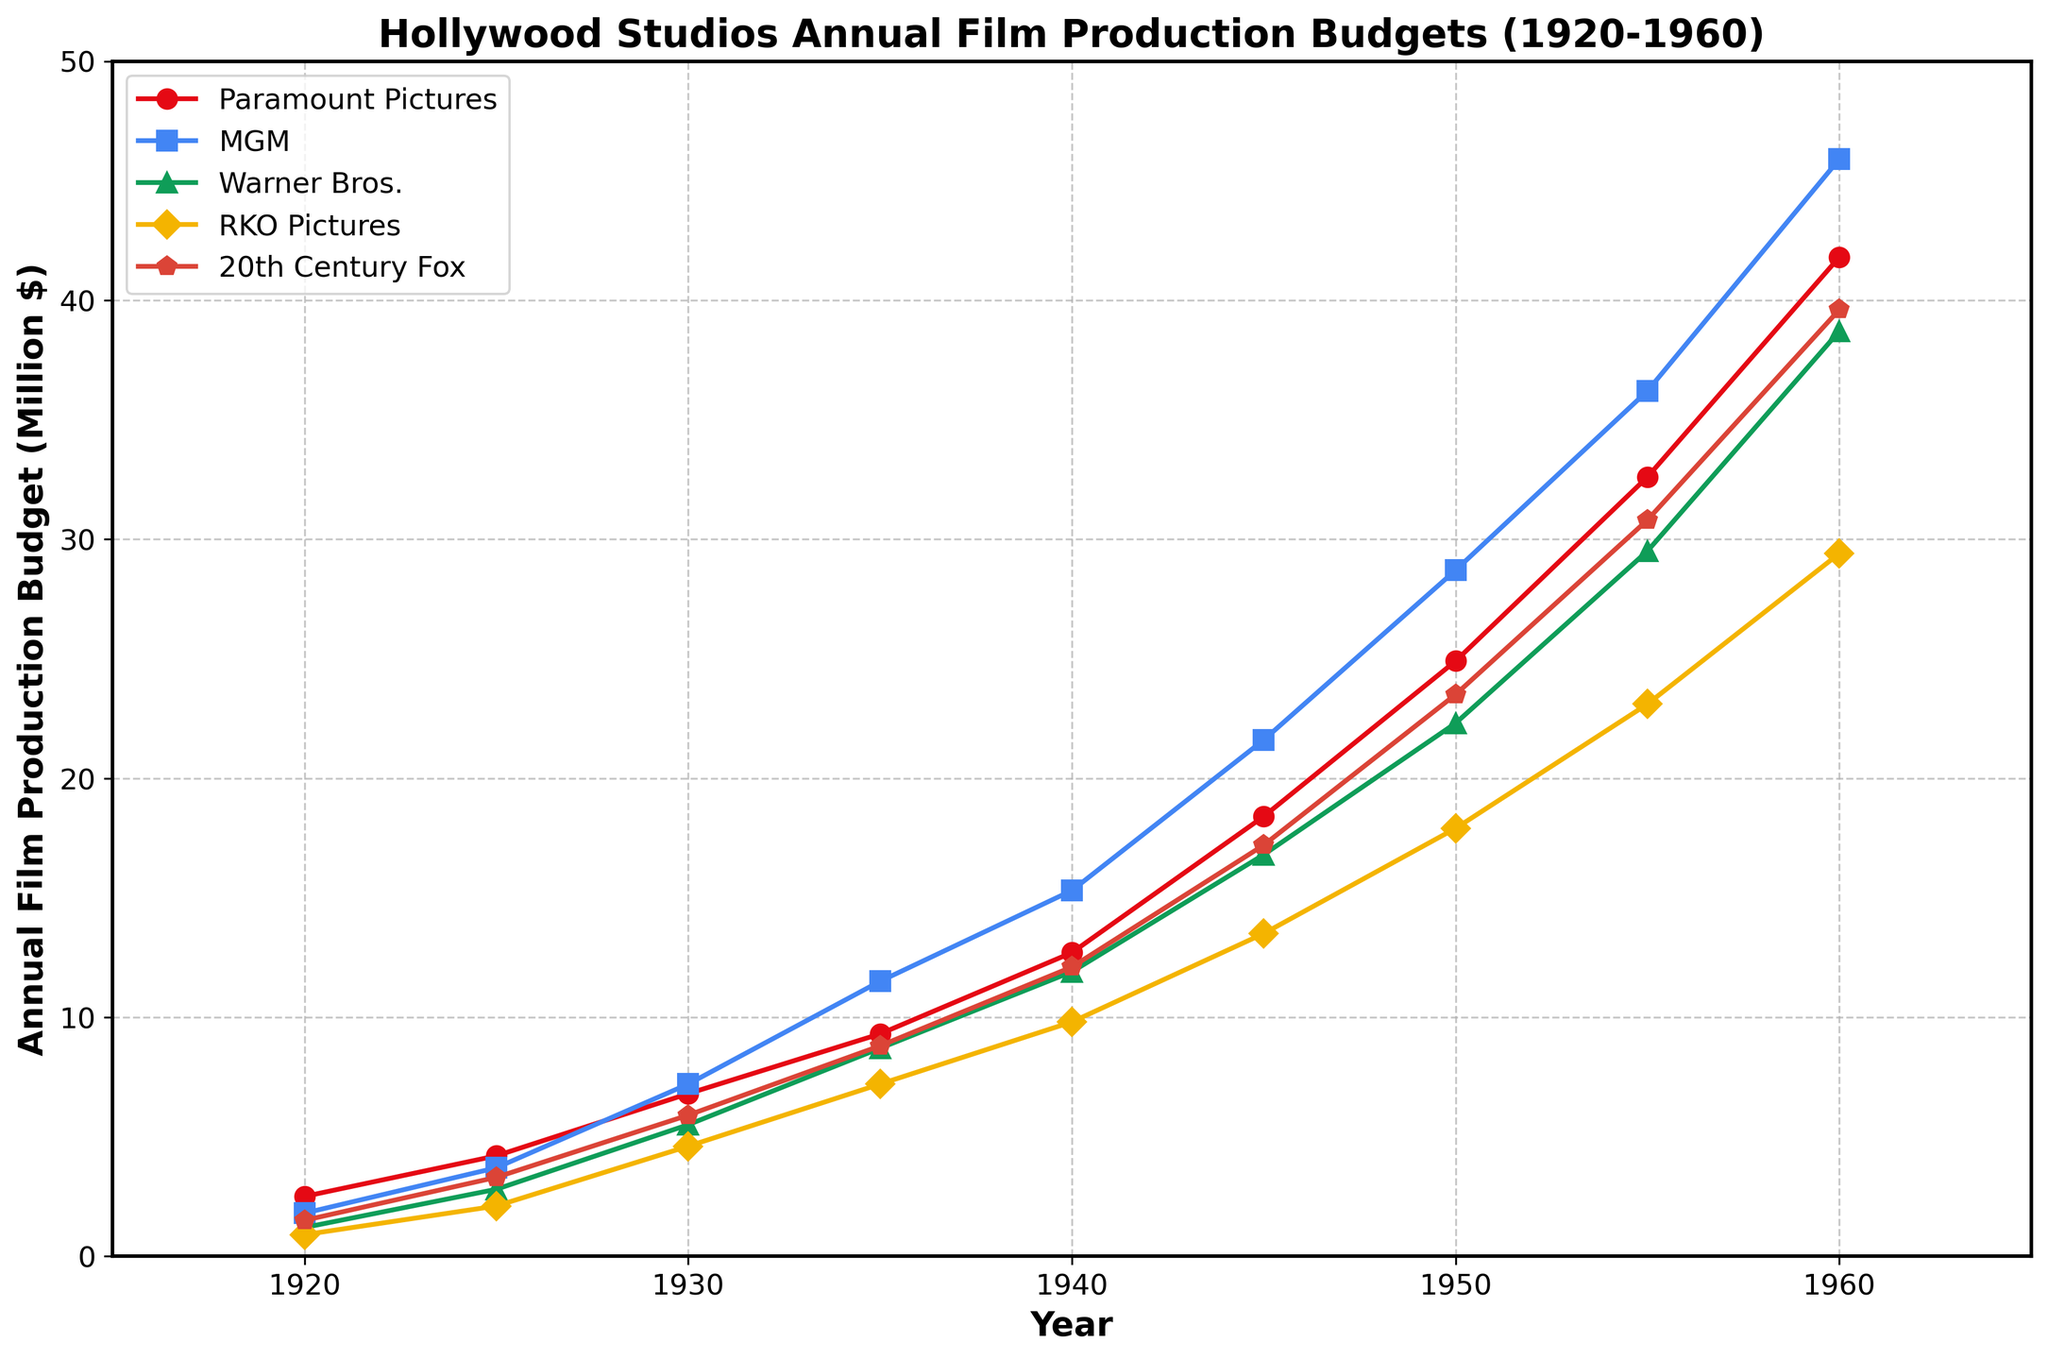What is the trend of annual film production budgets for MGM from 1920 to 1960? MGM's budget consistently increased from 1.8 million in 1920 to 45.9 million in 1960. I can see that the graph shows a steady upward trend for MGM through all the years displayed.
Answer: Upward trend Which studio had the highest annual film production budget in 1940? In 1940, the plot shows that MGM's budget was the highest at 15.3 million, compared to other studios' budgets for that year.
Answer: MGM Between Warner Bros. and RKO Pictures, which studio saw a larger absolute increase in their annual film production budget from 1925 to 1960? Warner Bros. increased from 2.8 million in 1925 to 38.7 million in 1960, an increase of 35.9 million. RKO Pictures increased from 2.1 million to 29.4 million, an increase of 27.3 million. So, Warner Bros. had a larger absolute increase.
Answer: Warner Bros What was the average annual film production budget for Paramount Pictures over the entire period (1920-1960)? Adding the budgets for Paramount Pictures (2.5, 4.2, 6.8, 9.3, 12.7, 18.4, 24.9, 32.6, 41.8) gives 153.2. Dividing by the number of years (9) gives an average of 153.2/9 = 17.02.
Answer: 17.02 million How much more did 20th Century Fox spend on annual film production in 1955 compared to their budget in 1935? 20th Century Fox's budget in 1955 was 30.8 million and in 1935 it was 8.8 million. The difference is 30.8 - 8.8 = 22 million.
Answer: 22 million Which studio had the smallest increase in annual film production budget from 1920 to 1930? From 1920 to 1930, Paramount Pictures increased from 2.5 to 6.8, MGM from 1.8 to 7.2, Warner Bros. from 1.2 to 5.5, RKO Pictures from 0.9 to 4.6, and 20th Century Fox from 1.5 to 5.9. The smallest increase is for RKO Pictures, which increased by 3.7 million.
Answer: RKO Pictures By how much did Warner Bros. exceed RKO Pictures in annual film production budget in 1960? In 1960, Warner Bros.' budget was 38.7 million, while RKO Pictures' budget was 29.4 million. The difference is 38.7 - 29.4 = 9.3 million.
Answer: 9.3 million What visual element indicates the studio with the highest budget in 1960? In the graph, the highest budget point in 1960 is reached by the blue line with a square marker, which represents MGM.
Answer: Blue line with a square marker Which studio showed the most consistent increase in their budgets over the years? Reviewing the chart, all studios show a consistent increasing trend, but MGM's line appears to be the smoothest and consistently rising, indicating the most consistent increase.
Answer: MGM What was the total annual film production budget for all five studios in 1945? Summing the budgets in 1945: Paramount Pictures 18.4, MGM 21.6, Warner Bros. 16.8, RKO Pictures 13.5, and 20th Century Fox 17.2. The total is 18.4 + 21.6 + 16.8 + 13.5 + 17.2 = 87.5 million.
Answer: 87.5 million 